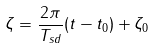Convert formula to latex. <formula><loc_0><loc_0><loc_500><loc_500>\zeta = \frac { 2 \pi } { T _ { s d } } ( t - t _ { 0 } ) + \zeta _ { 0 }</formula> 